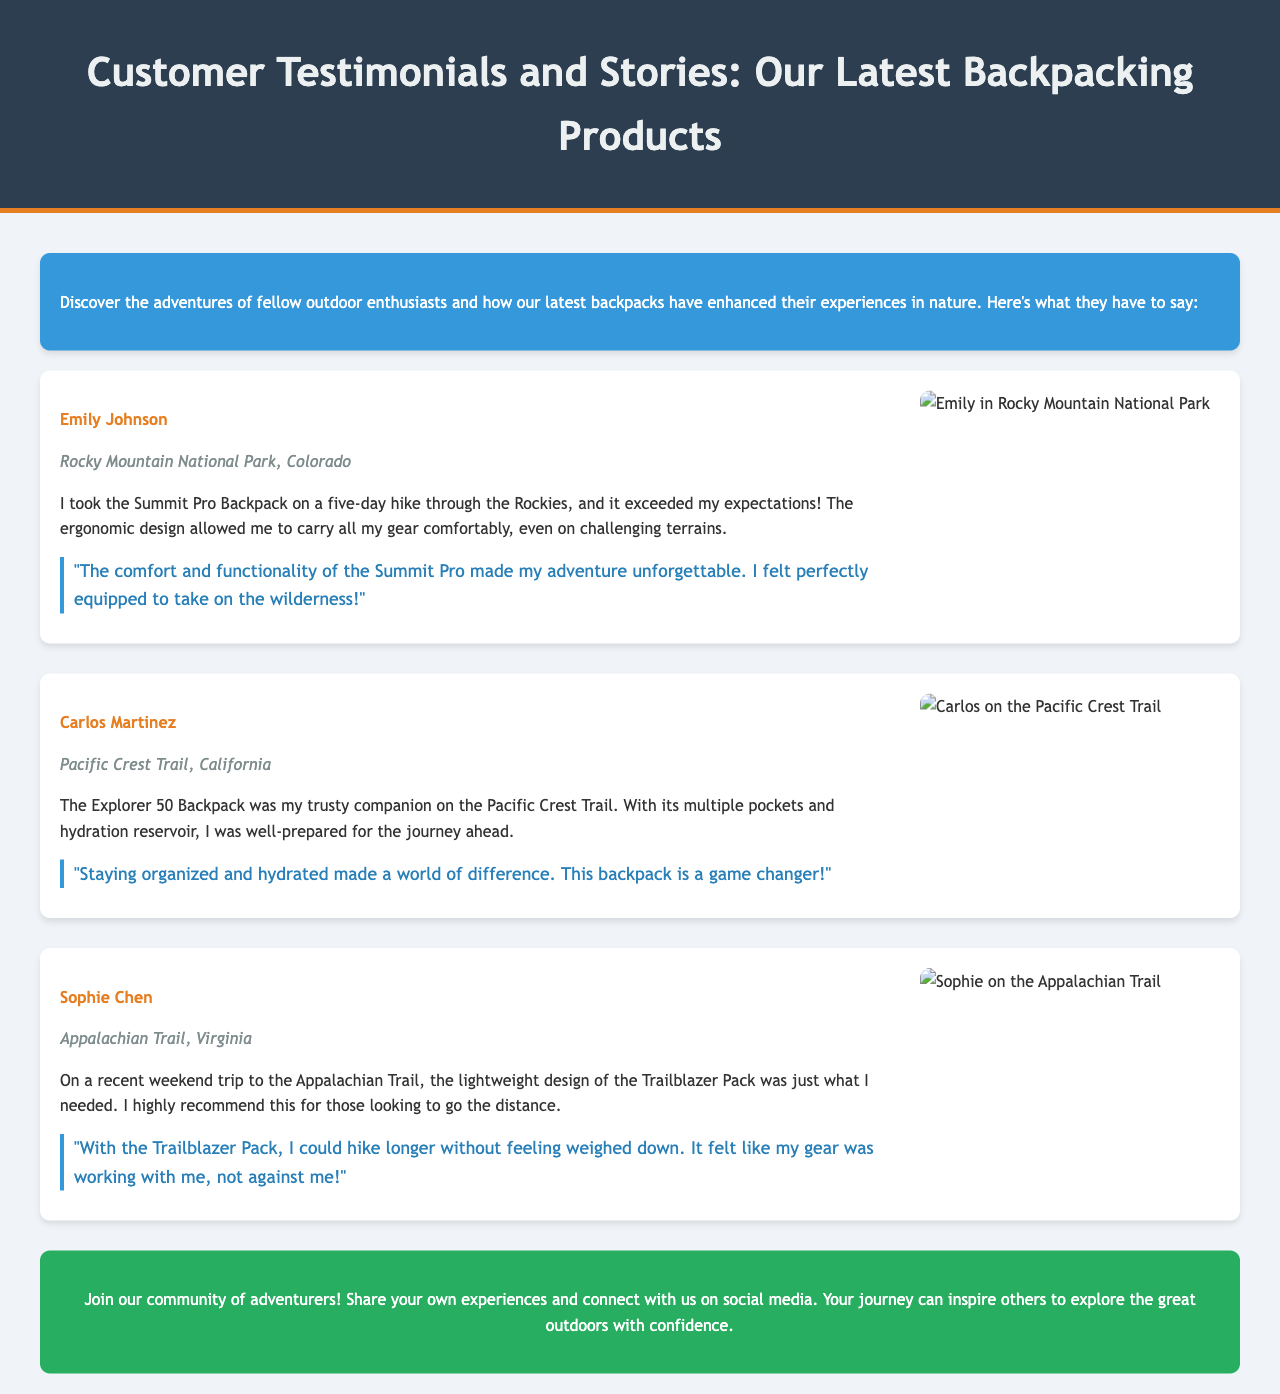What is the customer’s name who hiked in Rocky Mountain National Park? The document clearly states that Emily Johnson hiked in Rocky Mountain National Park.
Answer: Emily Johnson Which backpack did Carlos Martinez use on the Pacific Crest Trail? The document specifies that Carlos used the Explorer 50 Backpack.
Answer: Explorer 50 Backpack What is the quote from Sophie Chen about her experience with the Trailblazer Pack? The document includes Sophie’s quote regarding the Trailblazer Pack, emphasizing its lightweight design.
Answer: "With the Trailblazer Pack, I could hike longer without feeling weighed down." How many days did Emily Johnson hike with the Summit Pro Backpack? The document mentions that Emily hiked for a five-day trip.
Answer: five days What type of experience is shared in this document? The document features authentic customer experiences regarding the latest backpacks during their adventures.
Answer: authentic customer experiences What location did Sophie Chen explore with her backpack? The document indicates that Sophie hiked on the Appalachian Trail in Virginia.
Answer: Appalachian Trail, Virginia Which backpack was described as a game changer by Carlos Martinez? The document specifically mentions that the Explorer 50 Backpack is a game changer according to Carlos.
Answer: Explorer 50 Backpack What community action is encouraged at the end of the document? The conclusion section of the document invites readers to share their own experiences on social media.
Answer: Share your own experiences What is the theme of the testimonials and stories featured? The overarching theme is to showcase how the latest backpacks enhance outdoor adventures.
Answer: enhance outdoor adventures 